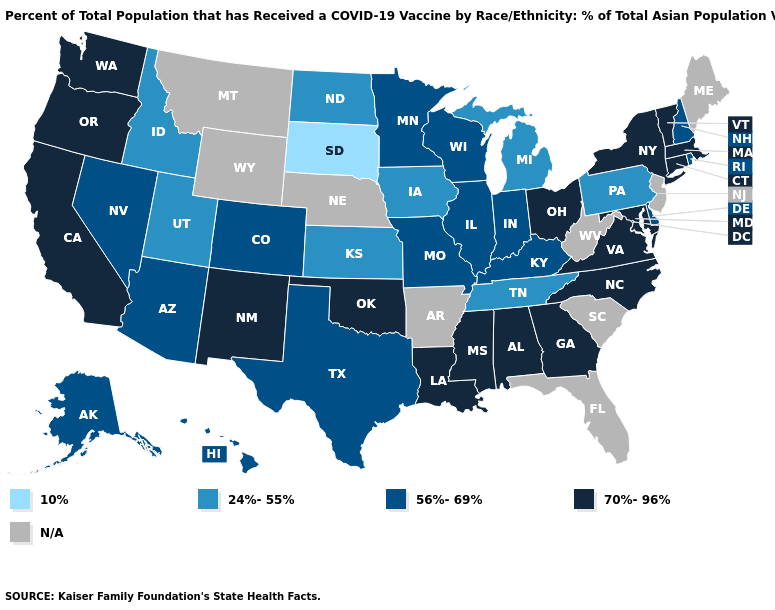Is the legend a continuous bar?
Write a very short answer. No. Name the states that have a value in the range 10%?
Concise answer only. South Dakota. What is the lowest value in the West?
Give a very brief answer. 24%-55%. What is the value of California?
Give a very brief answer. 70%-96%. Does the first symbol in the legend represent the smallest category?
Answer briefly. Yes. Name the states that have a value in the range 56%-69%?
Keep it brief. Alaska, Arizona, Colorado, Delaware, Hawaii, Illinois, Indiana, Kentucky, Minnesota, Missouri, Nevada, New Hampshire, Rhode Island, Texas, Wisconsin. What is the lowest value in states that border West Virginia?
Write a very short answer. 24%-55%. Does Massachusetts have the highest value in the USA?
Give a very brief answer. Yes. Which states have the lowest value in the MidWest?
Be succinct. South Dakota. Which states have the highest value in the USA?
Quick response, please. Alabama, California, Connecticut, Georgia, Louisiana, Maryland, Massachusetts, Mississippi, New Mexico, New York, North Carolina, Ohio, Oklahoma, Oregon, Vermont, Virginia, Washington. What is the value of Alaska?
Quick response, please. 56%-69%. What is the value of Utah?
Give a very brief answer. 24%-55%. Does South Dakota have the lowest value in the MidWest?
Answer briefly. Yes. 